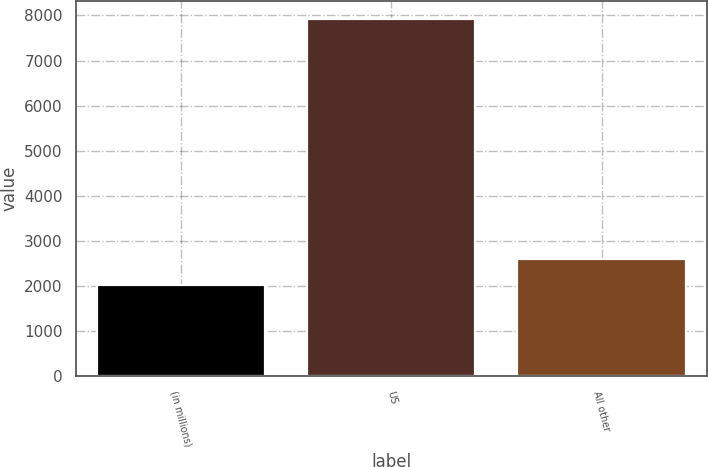<chart> <loc_0><loc_0><loc_500><loc_500><bar_chart><fcel>(in millions)<fcel>US<fcel>All other<nl><fcel>2014<fcel>7927<fcel>2605.3<nl></chart> 